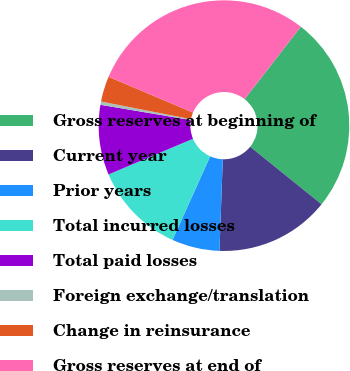Convert chart. <chart><loc_0><loc_0><loc_500><loc_500><pie_chart><fcel>Gross reserves at beginning of<fcel>Current year<fcel>Prior years<fcel>Total incurred losses<fcel>Total paid losses<fcel>Foreign exchange/translation<fcel>Change in reinsurance<fcel>Gross reserves at end of<nl><fcel>25.28%<fcel>14.78%<fcel>6.16%<fcel>11.9%<fcel>9.03%<fcel>0.42%<fcel>3.29%<fcel>29.13%<nl></chart> 